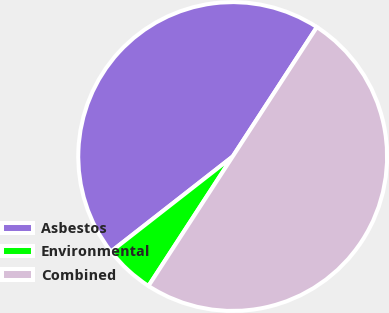Convert chart. <chart><loc_0><loc_0><loc_500><loc_500><pie_chart><fcel>Asbestos<fcel>Environmental<fcel>Combined<nl><fcel>44.73%<fcel>5.27%<fcel>50.0%<nl></chart> 